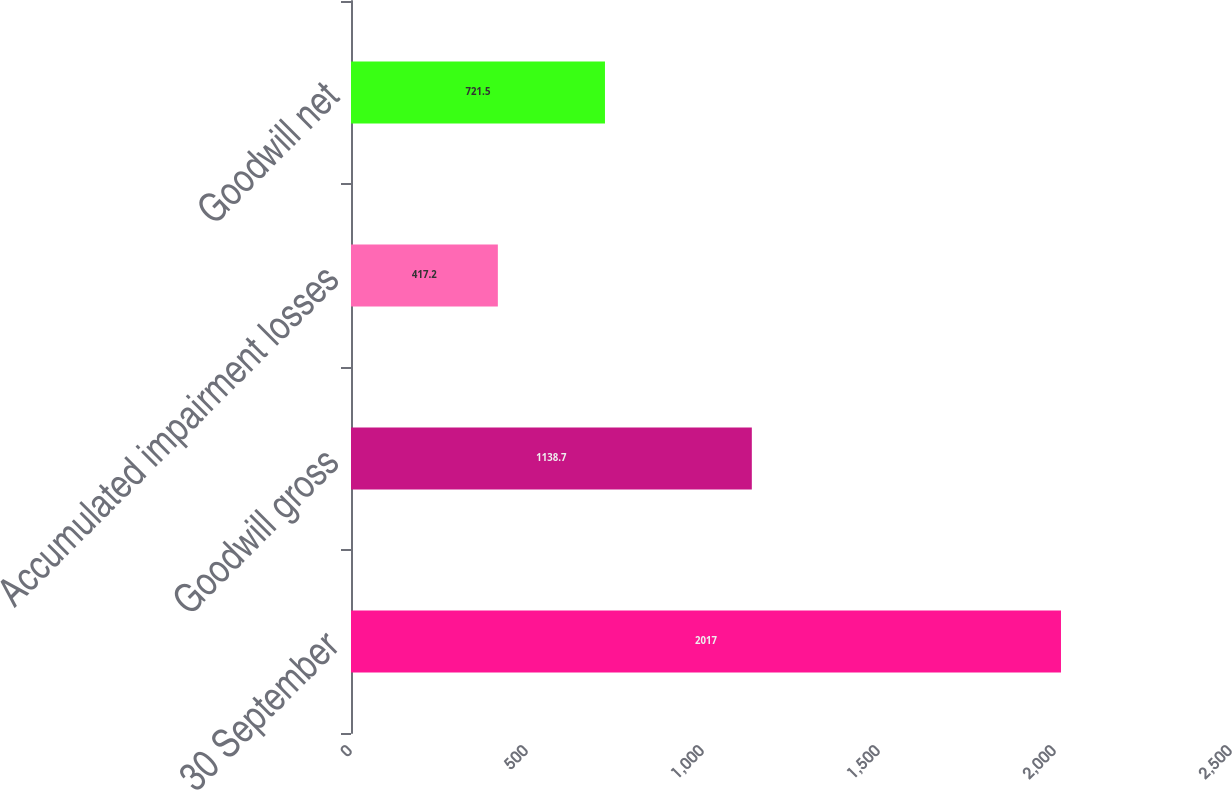Convert chart to OTSL. <chart><loc_0><loc_0><loc_500><loc_500><bar_chart><fcel>30 September<fcel>Goodwill gross<fcel>Accumulated impairment losses<fcel>Goodwill net<nl><fcel>2017<fcel>1138.7<fcel>417.2<fcel>721.5<nl></chart> 